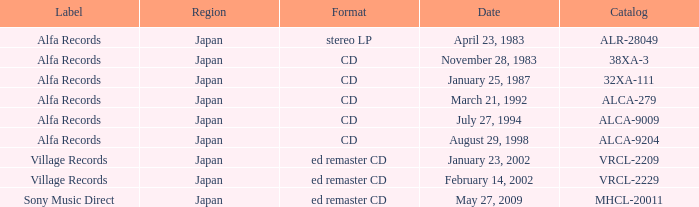What is the format of the date February 14, 2002? Ed remaster cd. 